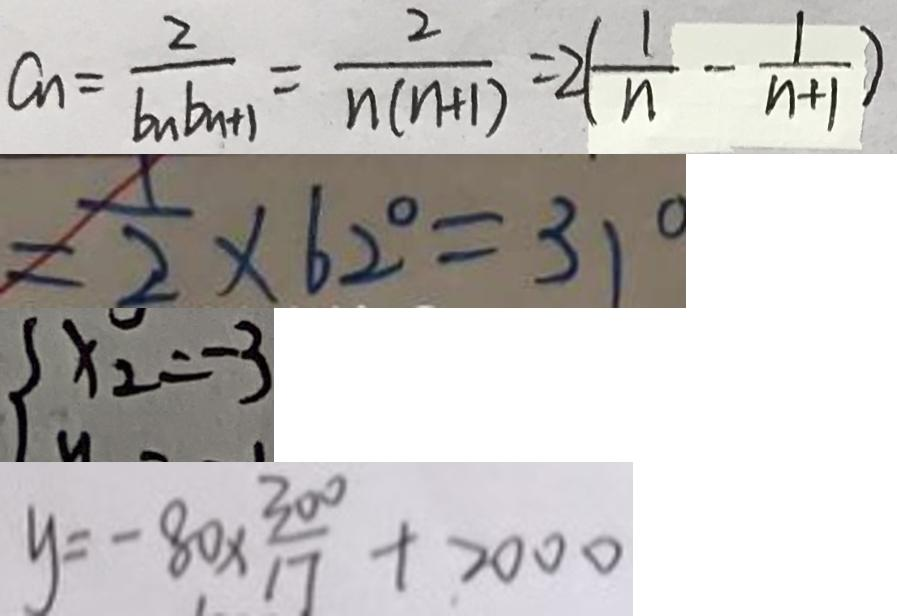Convert formula to latex. <formula><loc_0><loc_0><loc_500><loc_500>a _ { n } = \frac { 2 } { b _ { n } b _ { n + 1 } } = \frac { 2 } { n ( n + 1 ) } = 2 ( \frac { 1 } { n } - \frac { 1 } { n + 1 } ) 
 = \frac { 1 } { 2 } \times 6 2 ^ { \circ } = 3 1 ^ { \circ } 
 x _ { 2 } = - 3 
 y = - 8 0 \times \frac { 3 0 0 } { 1 7 } + 2 0 0 0</formula> 